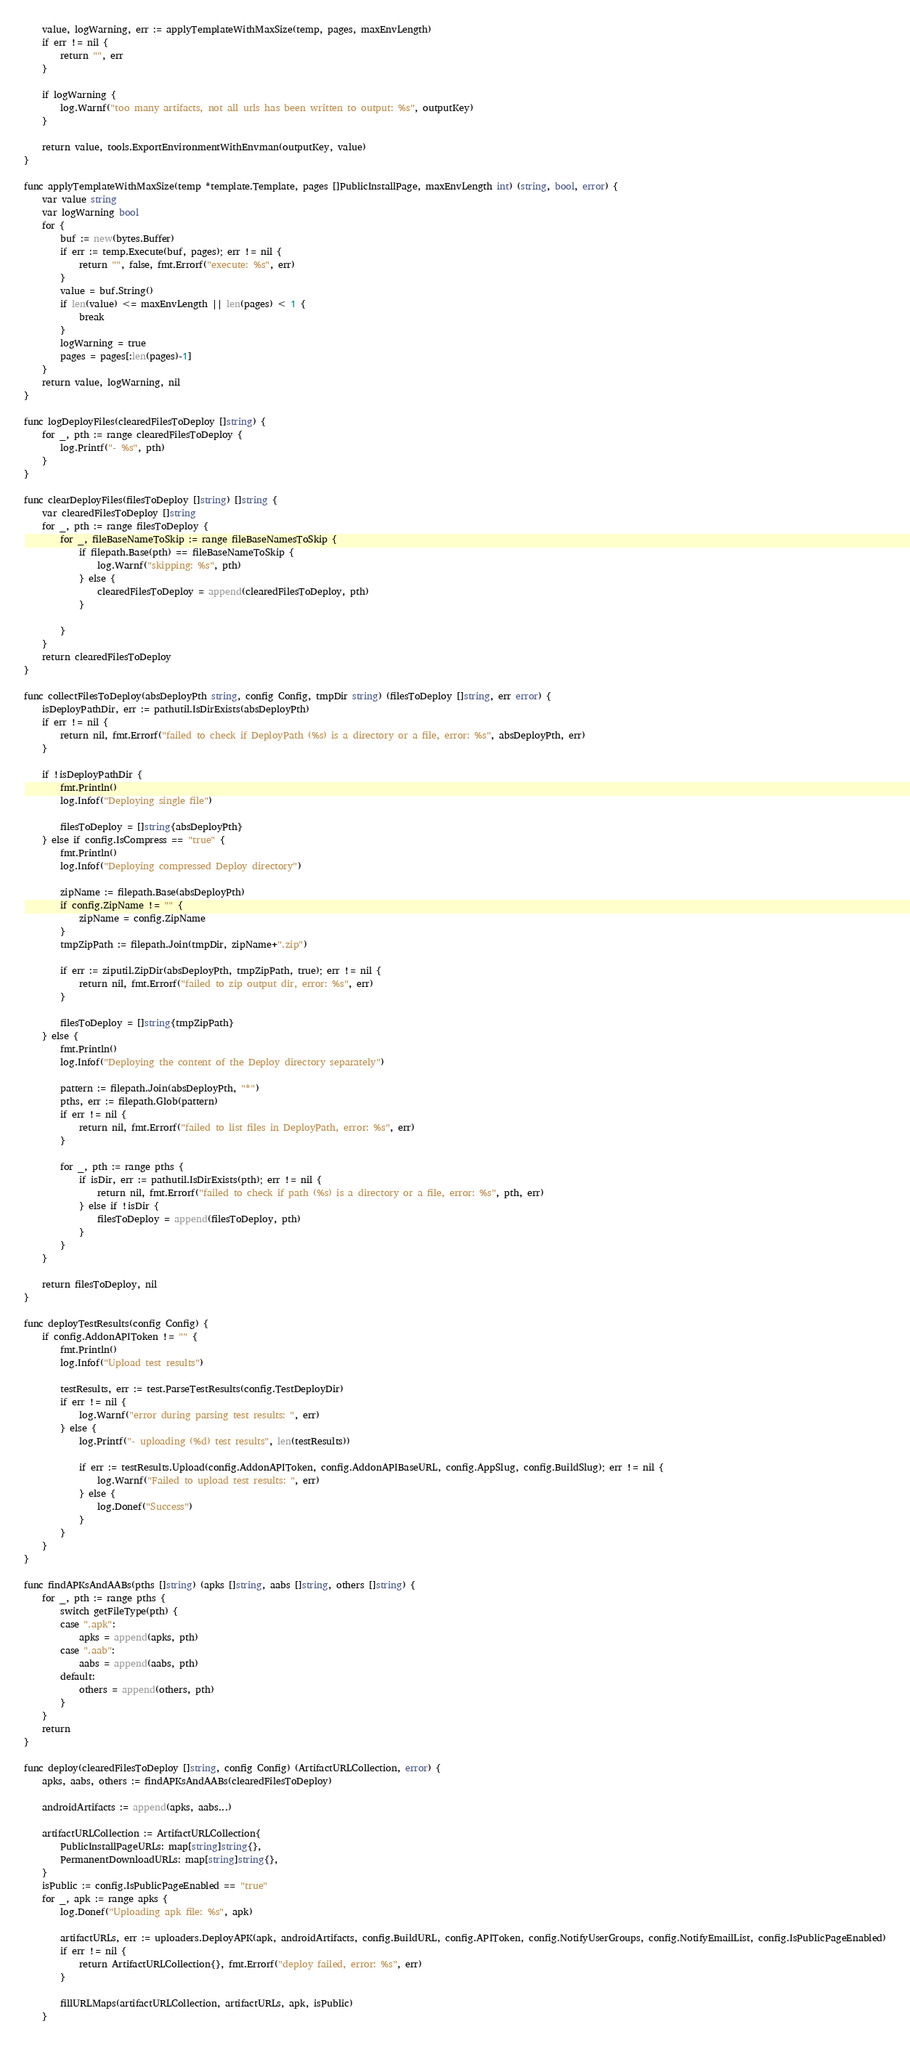Convert code to text. <code><loc_0><loc_0><loc_500><loc_500><_Go_>
    value, logWarning, err := applyTemplateWithMaxSize(temp, pages, maxEnvLength)
    if err != nil {
        return "", err
    }

    if logWarning {
        log.Warnf("too many artifacts, not all urls has been written to output: %s", outputKey)
    }

    return value, tools.ExportEnvironmentWithEnvman(outputKey, value)
}

func applyTemplateWithMaxSize(temp *template.Template, pages []PublicInstallPage, maxEnvLength int) (string, bool, error) {
    var value string
    var logWarning bool
    for {
        buf := new(bytes.Buffer)
        if err := temp.Execute(buf, pages); err != nil {
            return "", false, fmt.Errorf("execute: %s", err)
        }
        value = buf.String()
        if len(value) <= maxEnvLength || len(pages) < 1 {
            break
        }
        logWarning = true
        pages = pages[:len(pages)-1]
    }
    return value, logWarning, nil
}

func logDeployFiles(clearedFilesToDeploy []string) {
    for _, pth := range clearedFilesToDeploy {
        log.Printf("- %s", pth)
    }
}

func clearDeployFiles(filesToDeploy []string) []string {
    var clearedFilesToDeploy []string
    for _, pth := range filesToDeploy {
        for _, fileBaseNameToSkip := range fileBaseNamesToSkip {
            if filepath.Base(pth) == fileBaseNameToSkip {
                log.Warnf("skipping: %s", pth)
            } else {
                clearedFilesToDeploy = append(clearedFilesToDeploy, pth)
            }

        }
    }
    return clearedFilesToDeploy
}

func collectFilesToDeploy(absDeployPth string, config Config, tmpDir string) (filesToDeploy []string, err error) {
    isDeployPathDir, err := pathutil.IsDirExists(absDeployPth)
    if err != nil {
        return nil, fmt.Errorf("failed to check if DeployPath (%s) is a directory or a file, error: %s", absDeployPth, err)
    }

    if !isDeployPathDir {
        fmt.Println()
        log.Infof("Deploying single file")

        filesToDeploy = []string{absDeployPth}
    } else if config.IsCompress == "true" {
        fmt.Println()
        log.Infof("Deploying compressed Deploy directory")

        zipName := filepath.Base(absDeployPth)
        if config.ZipName != "" {
            zipName = config.ZipName
        }
        tmpZipPath := filepath.Join(tmpDir, zipName+".zip")

        if err := ziputil.ZipDir(absDeployPth, tmpZipPath, true); err != nil {
            return nil, fmt.Errorf("failed to zip output dir, error: %s", err)
        }

        filesToDeploy = []string{tmpZipPath}
    } else {
        fmt.Println()
        log.Infof("Deploying the content of the Deploy directory separately")

        pattern := filepath.Join(absDeployPth, "*")
        pths, err := filepath.Glob(pattern)
        if err != nil {
            return nil, fmt.Errorf("failed to list files in DeployPath, error: %s", err)
        }

        for _, pth := range pths {
            if isDir, err := pathutil.IsDirExists(pth); err != nil {
                return nil, fmt.Errorf("failed to check if path (%s) is a directory or a file, error: %s", pth, err)
            } else if !isDir {
                filesToDeploy = append(filesToDeploy, pth)
            }
        }
    }

    return filesToDeploy, nil
}

func deployTestResults(config Config) {
    if config.AddonAPIToken != "" {
        fmt.Println()
        log.Infof("Upload test results")

        testResults, err := test.ParseTestResults(config.TestDeployDir)
        if err != nil {
            log.Warnf("error during parsing test results: ", err)
        } else {
            log.Printf("- uploading (%d) test results", len(testResults))

            if err := testResults.Upload(config.AddonAPIToken, config.AddonAPIBaseURL, config.AppSlug, config.BuildSlug); err != nil {
                log.Warnf("Failed to upload test results: ", err)
            } else {
                log.Donef("Success")
            }
        }
    }
}

func findAPKsAndAABs(pths []string) (apks []string, aabs []string, others []string) {
    for _, pth := range pths {
        switch getFileType(pth) {
        case ".apk":
            apks = append(apks, pth)
        case ".aab":
            aabs = append(aabs, pth)
        default:
            others = append(others, pth)
        }
    }
    return
}

func deploy(clearedFilesToDeploy []string, config Config) (ArtifactURLCollection, error) {
    apks, aabs, others := findAPKsAndAABs(clearedFilesToDeploy)

    androidArtifacts := append(apks, aabs...)

    artifactURLCollection := ArtifactURLCollection{
        PublicInstallPageURLs: map[string]string{},
        PermanentDownloadURLs: map[string]string{},
    }
    isPublic := config.IsPublicPageEnabled == "true"
    for _, apk := range apks {
        log.Donef("Uploading apk file: %s", apk)

        artifactURLs, err := uploaders.DeployAPK(apk, androidArtifacts, config.BuildURL, config.APIToken, config.NotifyUserGroups, config.NotifyEmailList, config.IsPublicPageEnabled)
        if err != nil {
            return ArtifactURLCollection{}, fmt.Errorf("deploy failed, error: %s", err)
        }

        fillURLMaps(artifactURLCollection, artifactURLs, apk, isPublic)
    }
</code> 